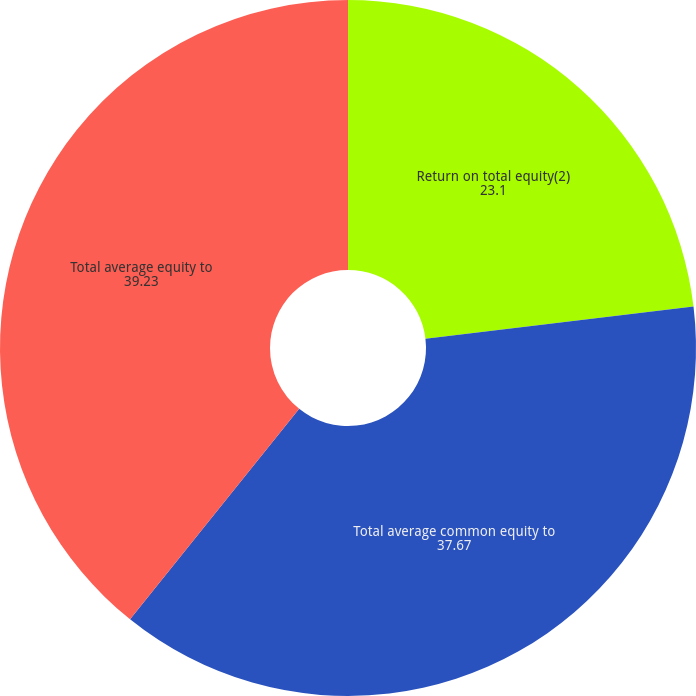Convert chart. <chart><loc_0><loc_0><loc_500><loc_500><pie_chart><fcel>Return on total equity(2)<fcel>Total average common equity to<fcel>Total average equity to<nl><fcel>23.1%<fcel>37.67%<fcel>39.23%<nl></chart> 